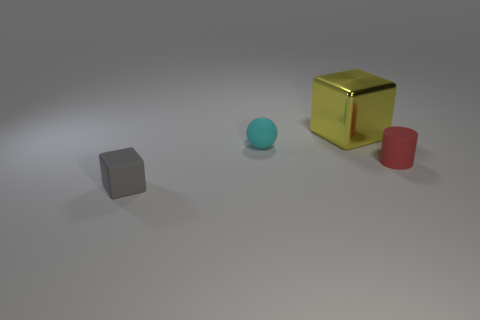There is a block that is on the right side of the matte cube; is there a small red rubber thing that is in front of it?
Keep it short and to the point. Yes. Is the number of matte cubes that are behind the cyan ball the same as the number of large yellow matte spheres?
Ensure brevity in your answer.  Yes. What number of tiny rubber objects are in front of the small thing that is behind the tiny thing to the right of the yellow metallic block?
Your response must be concise. 2. Are there any rubber cylinders of the same size as the gray object?
Ensure brevity in your answer.  Yes. Are there fewer large yellow things that are in front of the cyan thing than red rubber cylinders?
Provide a succinct answer. Yes. What is the tiny thing behind the rubber object that is on the right side of the block on the right side of the gray block made of?
Ensure brevity in your answer.  Rubber. Is the number of tiny red objects in front of the red rubber cylinder greater than the number of tiny matte cylinders that are to the left of the small matte ball?
Make the answer very short. No. How many metallic objects are tiny cyan cylinders or tiny cylinders?
Provide a succinct answer. 0. What is the small thing on the left side of the tiny sphere made of?
Provide a succinct answer. Rubber. How many objects are either tiny spheres or tiny gray matte things that are in front of the large cube?
Offer a very short reply. 2. 